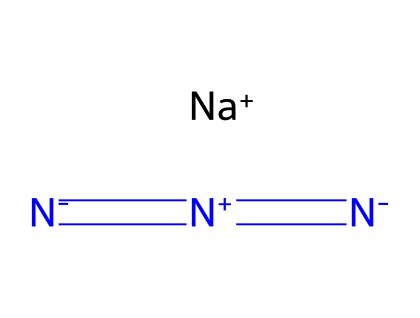What is the oxidation state of nitrogen in sodium azide? In sodium azide, the nitrogen atoms are in a chain with varying oxidation states. The terminal nitrogen has an oxidation state of -1, while the central nitrogens are +1. Therefore, the average oxidation state of all nitrogen atoms can be deduced to be 0 when considering the overall charge balance with sodium.
Answer: 0 How many nitrogen atoms are present in sodium azide? The SMILES notation shows three nitrogen atoms denoted as [N]. By counting the occurrences of [N] in the structure, we find there are three nitrogen atoms.
Answer: 3 What type of bonding is present between the nitrogen atoms in sodium azide? The nitrogen atoms in sodium azide are connected through double bonds, as indicated by the '=' symbols in the SMILES representation. This means there are double bonds between the nitrogen atoms, contributing to the stability and structure of the azide ion.
Answer: double bond What is the overall charge of sodium azide? The chemical structure indicates the presence of a sodium ion ([Na+]) and an azide ion ([N-]=[N+]=[N-]), where the azide ion carries a charge of -1. Therefore, the presence of the +1 sodium ion balances out the total charge to 0, making the overall compound neutral.
Answer: 0 Which ion in sodium azide is responsible for its azide properties? The azide properties are attributed to the azide ion, which comprises the nitrogen atoms connected through specific bonding arrangements. The unique properties of azides, such as their use in triggering reactions, are inherent to this ion.
Answer: azide ion What function does sodium serve in sodium azide? Sodium acts as a counterion that balances the charge of the azide ion, providing the necessary cation to stabilize the overall structure of the compound. The presence of sodium ensures that the azide ion remains electrically neutral, which is critical for the compound's stability.
Answer: counterion 